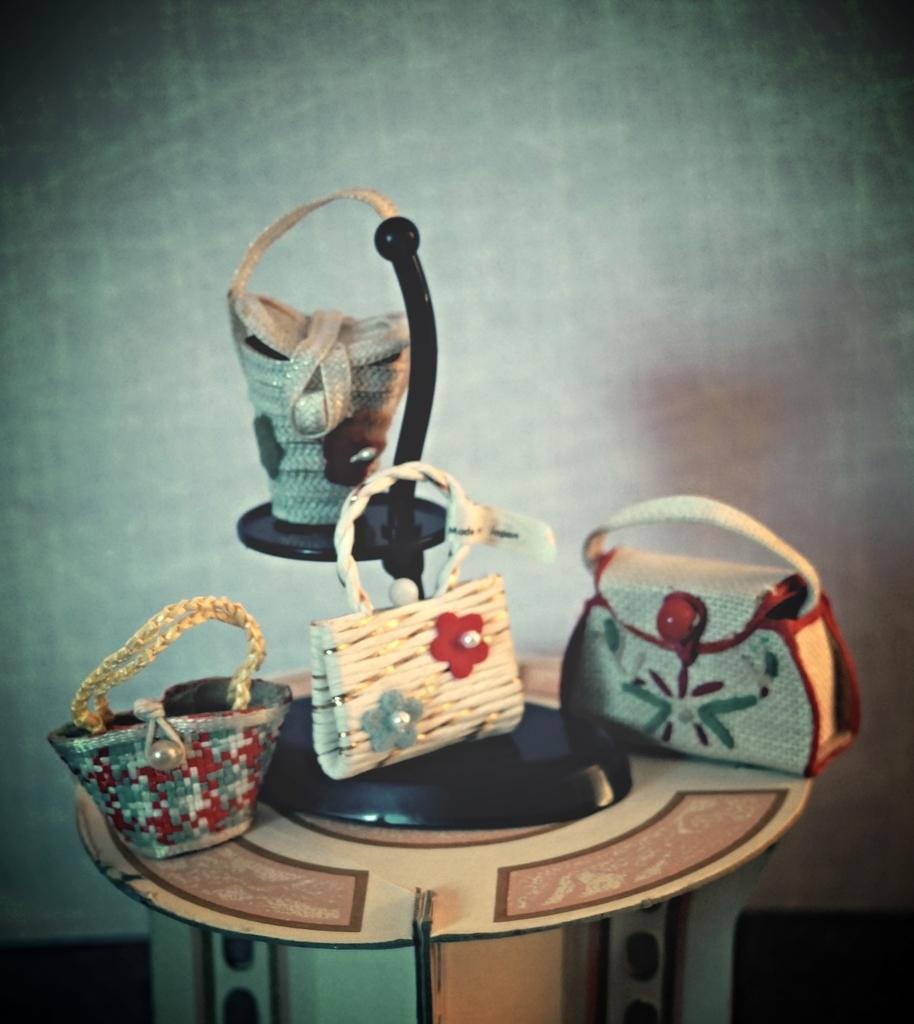How many handbags are visible in the image? There are four handbags in the image. What material are the handbags made of? The handbags are made of miniature art. What type of meat is being served in the image? There is no meat present in the image; it features four handbags made of miniature art. 